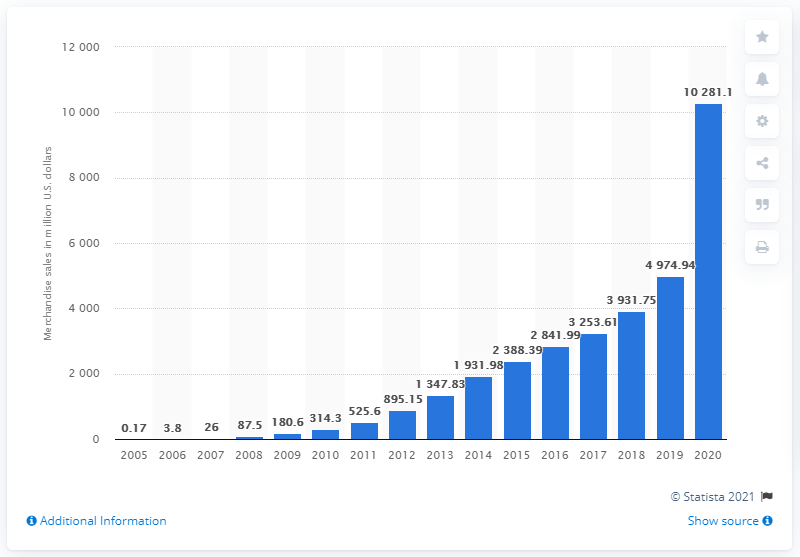What was Etsy's annual merchandise sales volume in dollars in 2020?
 10281.1 